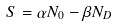Convert formula to latex. <formula><loc_0><loc_0><loc_500><loc_500>S = \alpha N _ { 0 } - \beta N _ { D }</formula> 